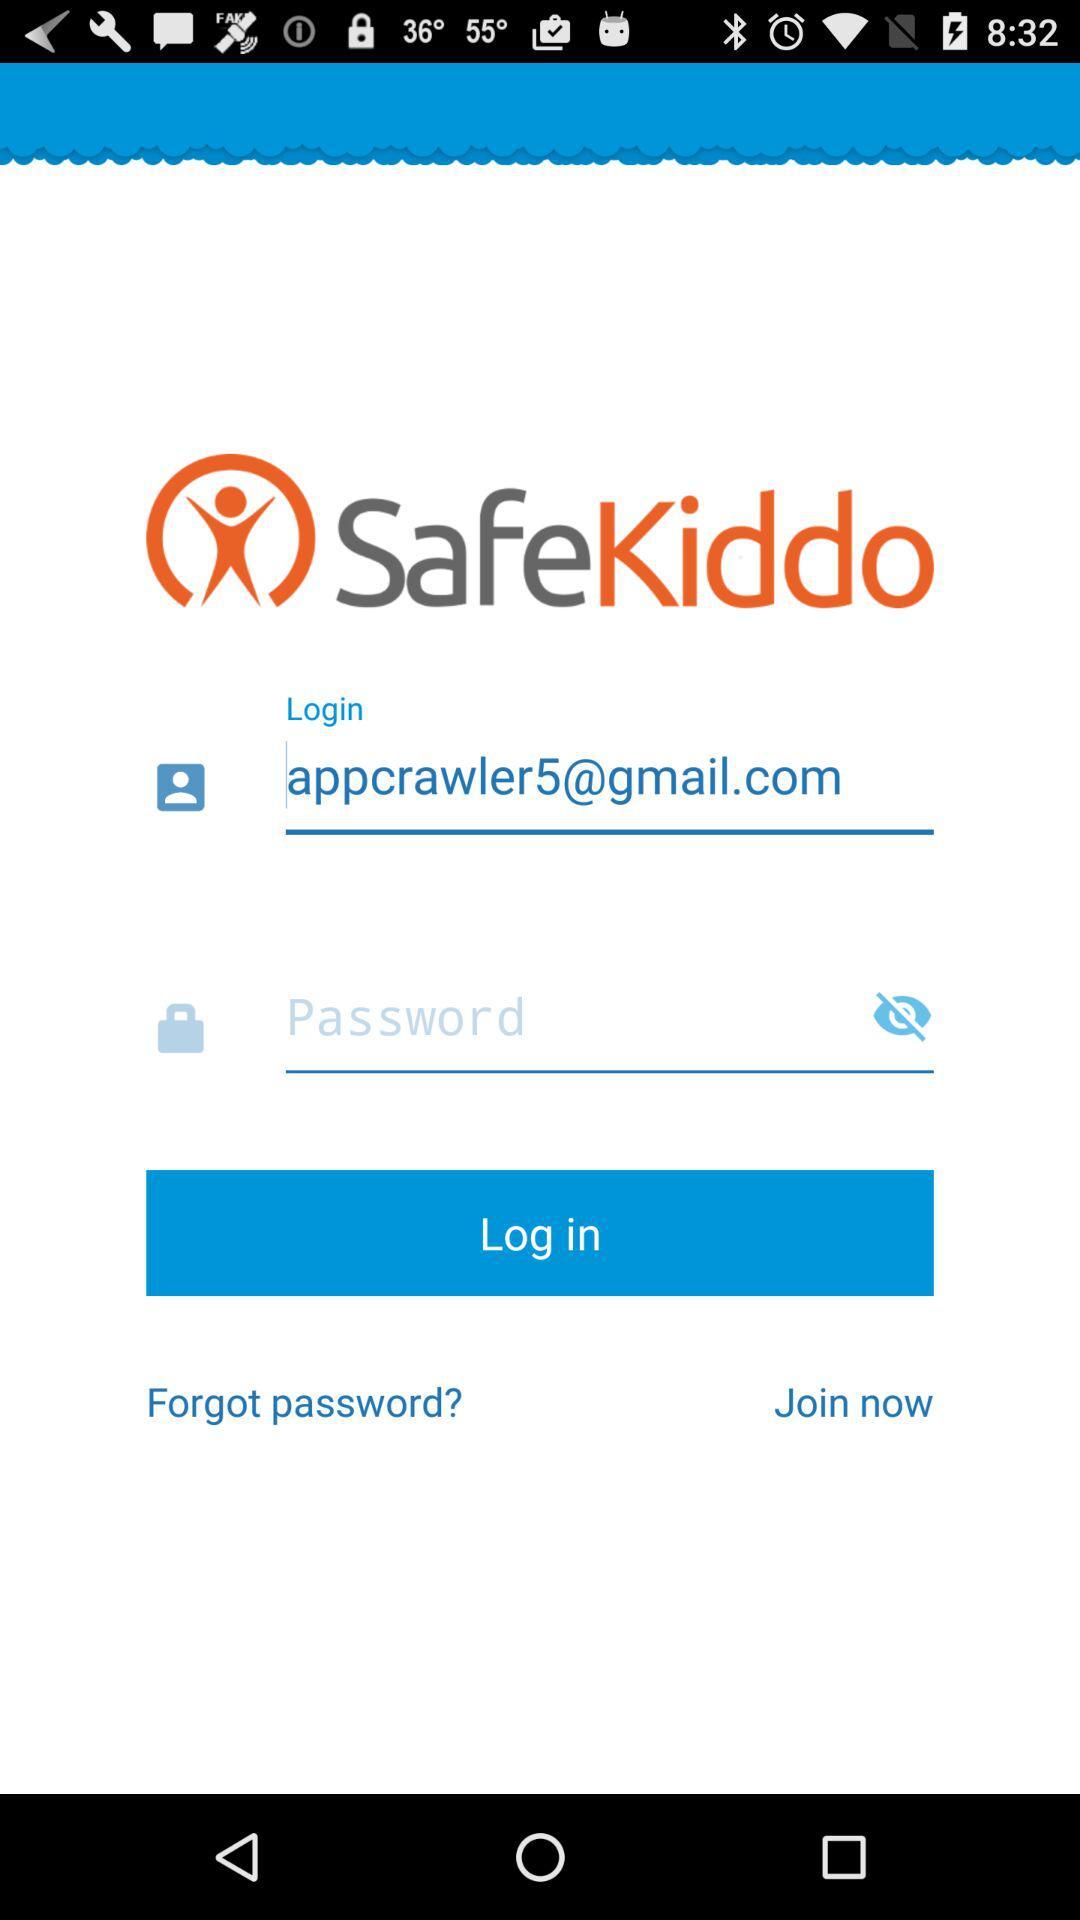What is the name of the application? The name of the application is "SafeKiddo". 